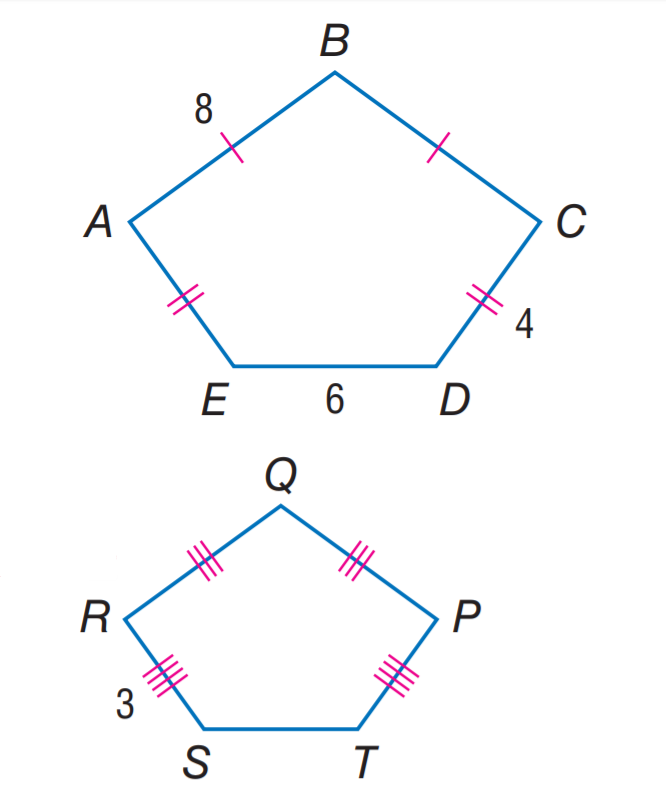Answer the mathemtical geometry problem and directly provide the correct option letter.
Question: If A B C D E \sim P Q R S T, find the perimeter of A B C D E.
Choices: A: 22.5 B: 27.5 C: 30 D: 35 C 